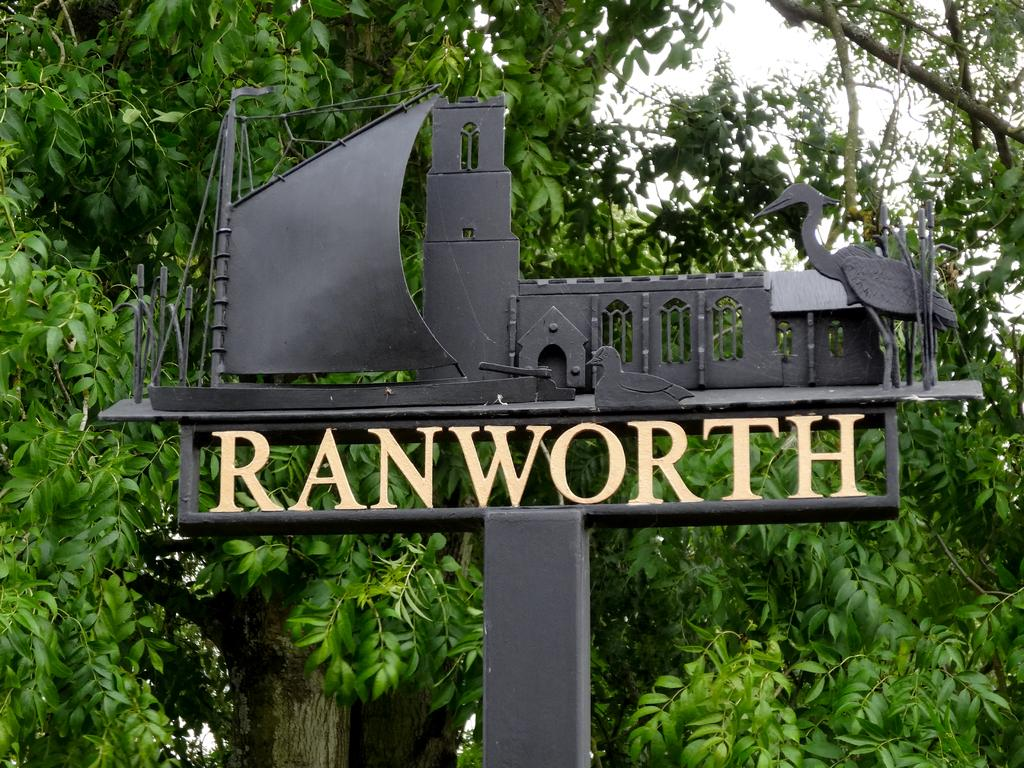What is the main subject of the image? The main subject of the image is a boat. What additional information is provided about the boat? There is text associated with the boat. What can be seen in the background of the image? There are trees in the background of the image. What is visible at the top of the image? The sky is visible at the top of the image. What type of leather is used to make the carpenter's tools in the image? There is no carpenter or tools present in the image; it features a boat with text and a background of trees and sky. How many balls are visible in the image? There are no balls present in the image. 